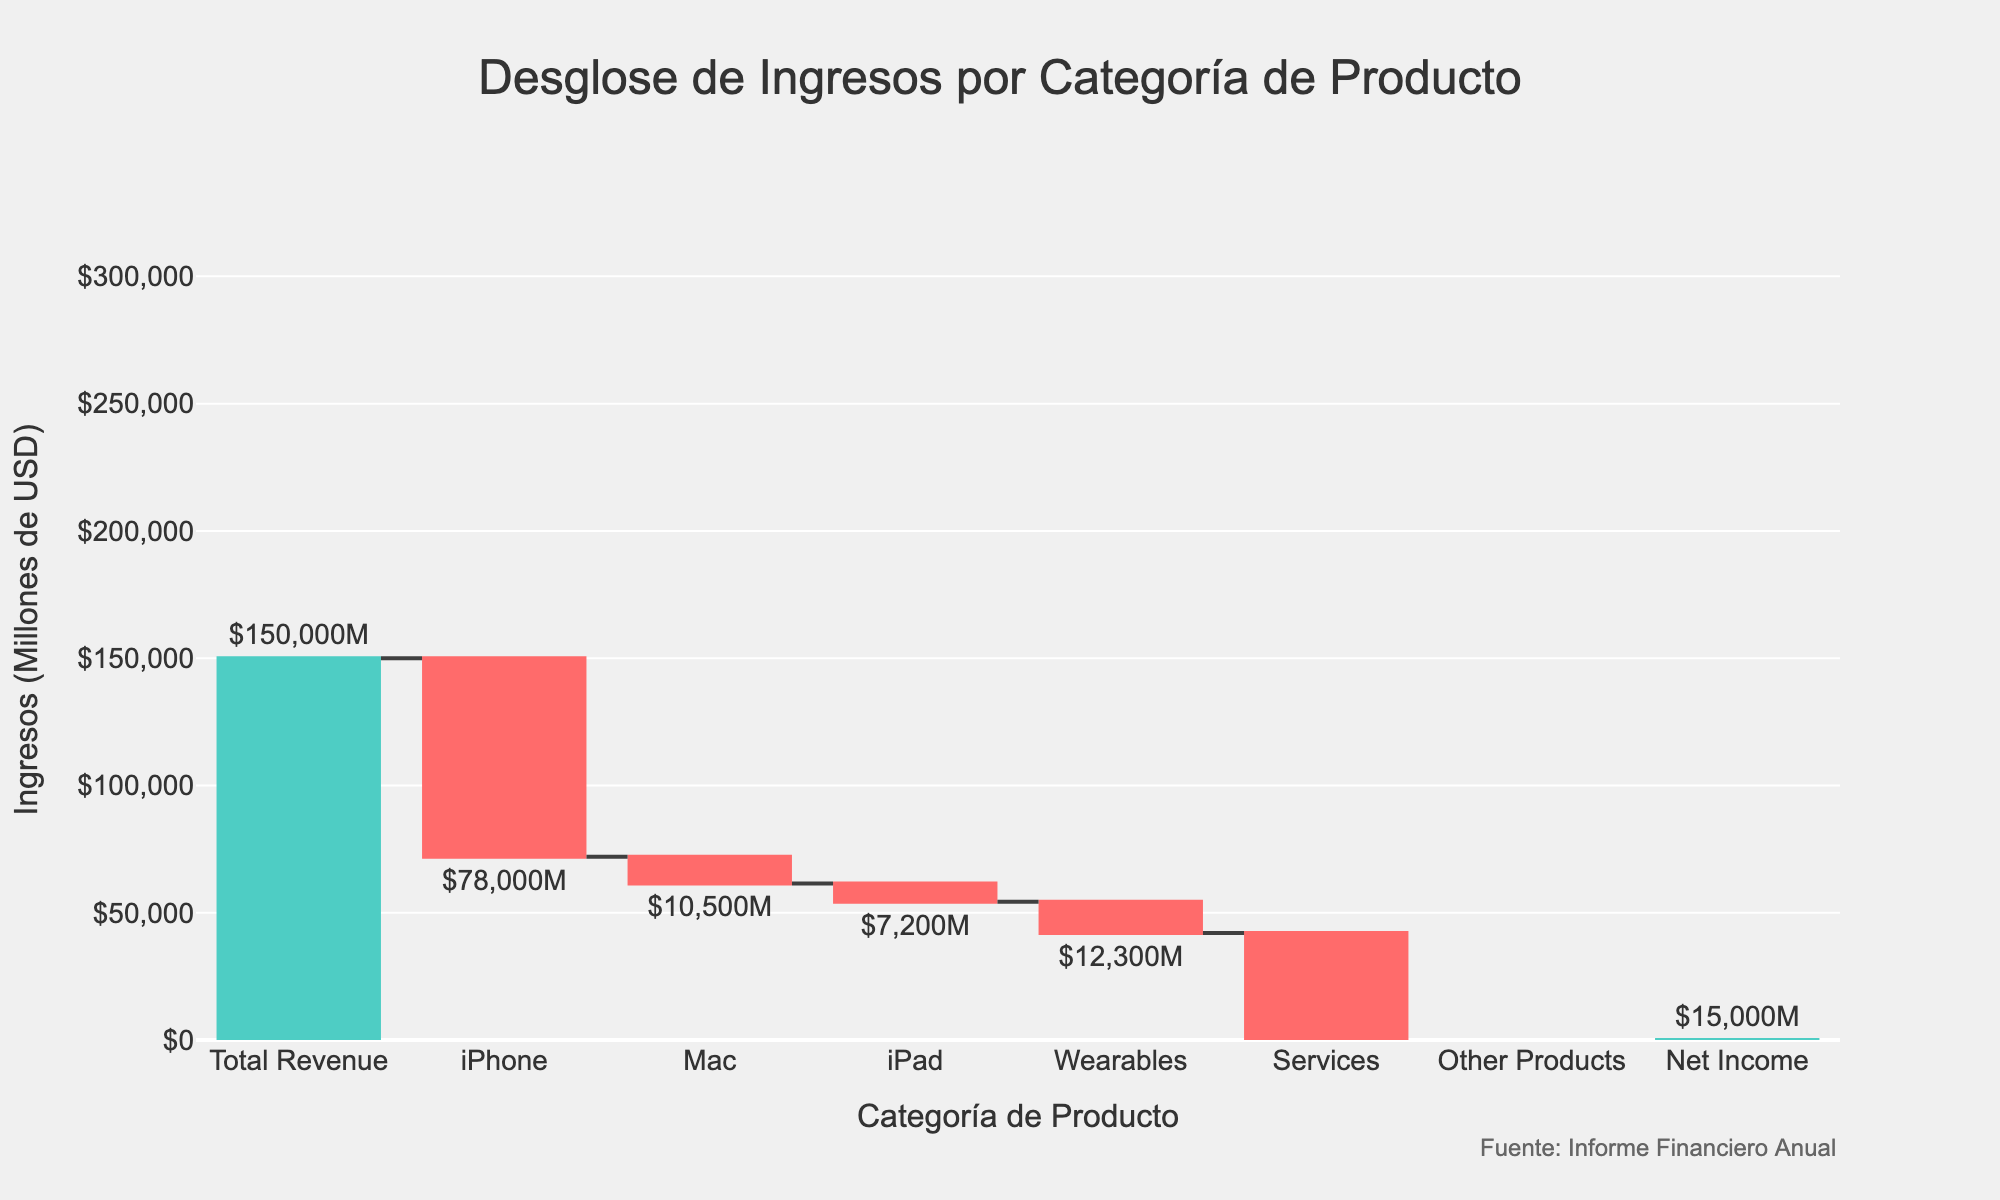What is the total revenue for the company according to the chart? The chart indicates the total revenue in the "Total Revenue" category, which is the first bar on the left.
Answer: $150,000 million How much revenue does the iPhone contribute according to the chart? The iPhone revenue is represented by one of the negative bars, with the label indicating its value.
Answer: $(78,000) million Which product category shows the least negative impact on the revenue? Among the negative bars, "Other Products" has the smallest drop in revenue, as illustrated by its smaller bar size compared to others like iPhone, Mac, etc.
Answer: $(3,000) million What is the net income after all categories have been accounted for? The net income is the final positive bar on the right of the chart, labeled accordingly.
Answer: $15,000 million How does the revenue from services compare to that from wearables? The revenue from services and wearables are both negative values shown as bars. Services have a higher negative value compared to wearables.
Answer: Services contribute $(54,000) million, while wearables contribute $(12,300) million What is the combined revenue impact from iPad and Wearables? According to the data, iPad contributes $(7,200) million and Wearables contribute $(12,300) million. Adding these two gives $(7,200) + $(12,300) = $(19,500) million.
Answer: $(19,500) million If the company managed to reduce the negative revenue from Mac by 50%, what would the revised revenue impact be for Mac? The current negative revenue from Mac is $(10,500) million. Reducing this by 50% results in $(10,500) x 0.50 = $(5,250) million.
Answer: $(5,250) million Which product category contributes the highest revenue after considering negative and positive values? Since all streams listed (apart from total revenue and net income) are negative and no individual product category has positive revenue, none contribute higher than the negative values already presented.
Answer: Services, with $(54,000) million How much is the combined revenue from all negative categories in the chart? Summing the negative revenues: $(78,000) + $(10,500) + $(7,200) + $(12,300) + $(54,000) + $(3,000) = $(165,000) million.
Answer: $(165,000) million 